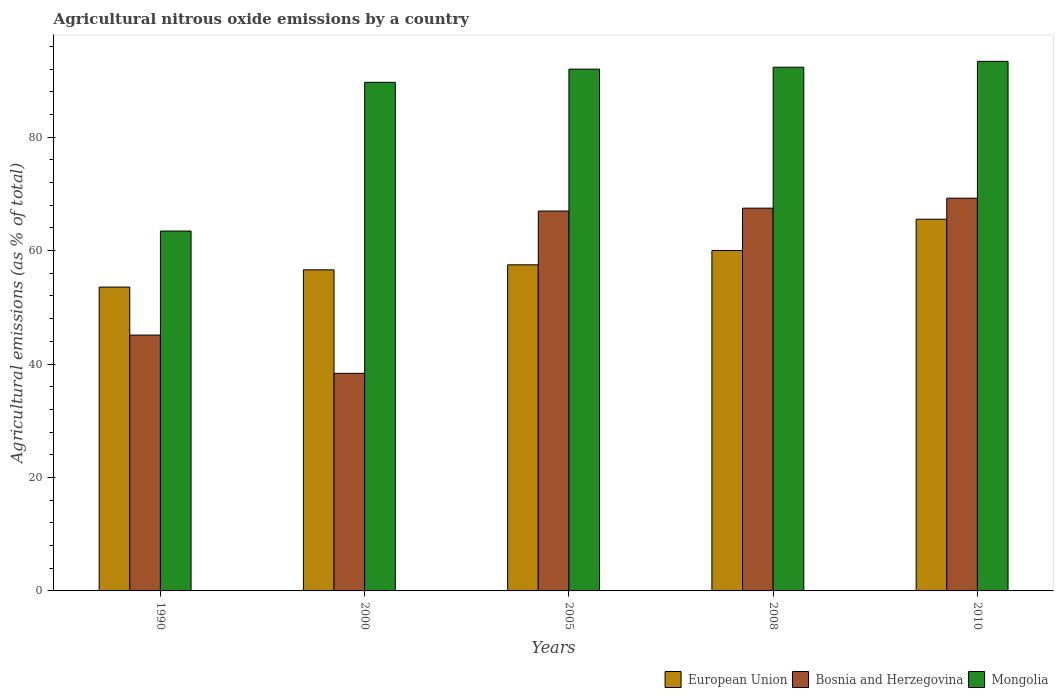How many different coloured bars are there?
Offer a terse response. 3. Are the number of bars per tick equal to the number of legend labels?
Provide a succinct answer. Yes. Are the number of bars on each tick of the X-axis equal?
Offer a terse response. Yes. How many bars are there on the 1st tick from the right?
Provide a short and direct response. 3. What is the label of the 5th group of bars from the left?
Give a very brief answer. 2010. In how many cases, is the number of bars for a given year not equal to the number of legend labels?
Keep it short and to the point. 0. What is the amount of agricultural nitrous oxide emitted in European Union in 2008?
Provide a succinct answer. 60.01. Across all years, what is the maximum amount of agricultural nitrous oxide emitted in European Union?
Your answer should be very brief. 65.53. Across all years, what is the minimum amount of agricultural nitrous oxide emitted in Mongolia?
Provide a short and direct response. 63.44. In which year was the amount of agricultural nitrous oxide emitted in European Union maximum?
Offer a terse response. 2010. In which year was the amount of agricultural nitrous oxide emitted in European Union minimum?
Give a very brief answer. 1990. What is the total amount of agricultural nitrous oxide emitted in European Union in the graph?
Give a very brief answer. 293.19. What is the difference between the amount of agricultural nitrous oxide emitted in European Union in 2000 and that in 2010?
Give a very brief answer. -8.93. What is the difference between the amount of agricultural nitrous oxide emitted in Mongolia in 2008 and the amount of agricultural nitrous oxide emitted in Bosnia and Herzegovina in 2010?
Offer a terse response. 23.09. What is the average amount of agricultural nitrous oxide emitted in Bosnia and Herzegovina per year?
Make the answer very short. 57.43. In the year 1990, what is the difference between the amount of agricultural nitrous oxide emitted in European Union and amount of agricultural nitrous oxide emitted in Bosnia and Herzegovina?
Make the answer very short. 8.46. In how many years, is the amount of agricultural nitrous oxide emitted in European Union greater than 48 %?
Your response must be concise. 5. What is the ratio of the amount of agricultural nitrous oxide emitted in European Union in 2000 to that in 2008?
Provide a succinct answer. 0.94. Is the difference between the amount of agricultural nitrous oxide emitted in European Union in 2005 and 2010 greater than the difference between the amount of agricultural nitrous oxide emitted in Bosnia and Herzegovina in 2005 and 2010?
Provide a succinct answer. No. What is the difference between the highest and the second highest amount of agricultural nitrous oxide emitted in European Union?
Your answer should be compact. 5.51. What is the difference between the highest and the lowest amount of agricultural nitrous oxide emitted in Bosnia and Herzegovina?
Give a very brief answer. 30.88. In how many years, is the amount of agricultural nitrous oxide emitted in European Union greater than the average amount of agricultural nitrous oxide emitted in European Union taken over all years?
Give a very brief answer. 2. Is the sum of the amount of agricultural nitrous oxide emitted in Mongolia in 2005 and 2010 greater than the maximum amount of agricultural nitrous oxide emitted in Bosnia and Herzegovina across all years?
Give a very brief answer. Yes. What does the 2nd bar from the right in 1990 represents?
Offer a terse response. Bosnia and Herzegovina. Is it the case that in every year, the sum of the amount of agricultural nitrous oxide emitted in Mongolia and amount of agricultural nitrous oxide emitted in European Union is greater than the amount of agricultural nitrous oxide emitted in Bosnia and Herzegovina?
Provide a short and direct response. Yes. Are all the bars in the graph horizontal?
Provide a short and direct response. No. Are the values on the major ticks of Y-axis written in scientific E-notation?
Your answer should be very brief. No. Does the graph contain any zero values?
Make the answer very short. No. Does the graph contain grids?
Your answer should be compact. No. Where does the legend appear in the graph?
Offer a very short reply. Bottom right. How many legend labels are there?
Give a very brief answer. 3. How are the legend labels stacked?
Your answer should be very brief. Horizontal. What is the title of the graph?
Your answer should be compact. Agricultural nitrous oxide emissions by a country. What is the label or title of the Y-axis?
Offer a very short reply. Agricultural emissions (as % of total). What is the Agricultural emissions (as % of total) of European Union in 1990?
Offer a very short reply. 53.56. What is the Agricultural emissions (as % of total) in Bosnia and Herzegovina in 1990?
Ensure brevity in your answer.  45.1. What is the Agricultural emissions (as % of total) of Mongolia in 1990?
Provide a short and direct response. 63.44. What is the Agricultural emissions (as % of total) of European Union in 2000?
Offer a terse response. 56.6. What is the Agricultural emissions (as % of total) in Bosnia and Herzegovina in 2000?
Your answer should be compact. 38.36. What is the Agricultural emissions (as % of total) of Mongolia in 2000?
Provide a succinct answer. 89.66. What is the Agricultural emissions (as % of total) in European Union in 2005?
Your response must be concise. 57.49. What is the Agricultural emissions (as % of total) in Bosnia and Herzegovina in 2005?
Give a very brief answer. 66.97. What is the Agricultural emissions (as % of total) of Mongolia in 2005?
Ensure brevity in your answer.  91.98. What is the Agricultural emissions (as % of total) of European Union in 2008?
Your answer should be very brief. 60.01. What is the Agricultural emissions (as % of total) of Bosnia and Herzegovina in 2008?
Provide a succinct answer. 67.47. What is the Agricultural emissions (as % of total) in Mongolia in 2008?
Offer a terse response. 92.32. What is the Agricultural emissions (as % of total) in European Union in 2010?
Ensure brevity in your answer.  65.53. What is the Agricultural emissions (as % of total) in Bosnia and Herzegovina in 2010?
Your response must be concise. 69.23. What is the Agricultural emissions (as % of total) of Mongolia in 2010?
Offer a very short reply. 93.35. Across all years, what is the maximum Agricultural emissions (as % of total) in European Union?
Your answer should be very brief. 65.53. Across all years, what is the maximum Agricultural emissions (as % of total) of Bosnia and Herzegovina?
Provide a short and direct response. 69.23. Across all years, what is the maximum Agricultural emissions (as % of total) of Mongolia?
Offer a very short reply. 93.35. Across all years, what is the minimum Agricultural emissions (as % of total) in European Union?
Ensure brevity in your answer.  53.56. Across all years, what is the minimum Agricultural emissions (as % of total) in Bosnia and Herzegovina?
Offer a very short reply. 38.36. Across all years, what is the minimum Agricultural emissions (as % of total) in Mongolia?
Offer a very short reply. 63.44. What is the total Agricultural emissions (as % of total) of European Union in the graph?
Provide a short and direct response. 293.19. What is the total Agricultural emissions (as % of total) of Bosnia and Herzegovina in the graph?
Keep it short and to the point. 287.13. What is the total Agricultural emissions (as % of total) of Mongolia in the graph?
Provide a succinct answer. 430.75. What is the difference between the Agricultural emissions (as % of total) in European Union in 1990 and that in 2000?
Provide a succinct answer. -3.04. What is the difference between the Agricultural emissions (as % of total) of Bosnia and Herzegovina in 1990 and that in 2000?
Provide a succinct answer. 6.74. What is the difference between the Agricultural emissions (as % of total) of Mongolia in 1990 and that in 2000?
Keep it short and to the point. -26.22. What is the difference between the Agricultural emissions (as % of total) in European Union in 1990 and that in 2005?
Offer a very short reply. -3.92. What is the difference between the Agricultural emissions (as % of total) of Bosnia and Herzegovina in 1990 and that in 2005?
Your answer should be compact. -21.87. What is the difference between the Agricultural emissions (as % of total) of Mongolia in 1990 and that in 2005?
Provide a succinct answer. -28.54. What is the difference between the Agricultural emissions (as % of total) of European Union in 1990 and that in 2008?
Keep it short and to the point. -6.45. What is the difference between the Agricultural emissions (as % of total) in Bosnia and Herzegovina in 1990 and that in 2008?
Your answer should be very brief. -22.37. What is the difference between the Agricultural emissions (as % of total) in Mongolia in 1990 and that in 2008?
Your response must be concise. -28.88. What is the difference between the Agricultural emissions (as % of total) of European Union in 1990 and that in 2010?
Give a very brief answer. -11.97. What is the difference between the Agricultural emissions (as % of total) in Bosnia and Herzegovina in 1990 and that in 2010?
Offer a very short reply. -24.13. What is the difference between the Agricultural emissions (as % of total) of Mongolia in 1990 and that in 2010?
Your response must be concise. -29.91. What is the difference between the Agricultural emissions (as % of total) in European Union in 2000 and that in 2005?
Keep it short and to the point. -0.89. What is the difference between the Agricultural emissions (as % of total) in Bosnia and Herzegovina in 2000 and that in 2005?
Provide a short and direct response. -28.61. What is the difference between the Agricultural emissions (as % of total) in Mongolia in 2000 and that in 2005?
Offer a very short reply. -2.32. What is the difference between the Agricultural emissions (as % of total) of European Union in 2000 and that in 2008?
Provide a succinct answer. -3.41. What is the difference between the Agricultural emissions (as % of total) of Bosnia and Herzegovina in 2000 and that in 2008?
Offer a very short reply. -29.12. What is the difference between the Agricultural emissions (as % of total) of Mongolia in 2000 and that in 2008?
Provide a short and direct response. -2.66. What is the difference between the Agricultural emissions (as % of total) in European Union in 2000 and that in 2010?
Offer a very short reply. -8.93. What is the difference between the Agricultural emissions (as % of total) of Bosnia and Herzegovina in 2000 and that in 2010?
Your answer should be compact. -30.88. What is the difference between the Agricultural emissions (as % of total) of Mongolia in 2000 and that in 2010?
Keep it short and to the point. -3.7. What is the difference between the Agricultural emissions (as % of total) in European Union in 2005 and that in 2008?
Ensure brevity in your answer.  -2.53. What is the difference between the Agricultural emissions (as % of total) in Bosnia and Herzegovina in 2005 and that in 2008?
Your response must be concise. -0.51. What is the difference between the Agricultural emissions (as % of total) of Mongolia in 2005 and that in 2008?
Give a very brief answer. -0.34. What is the difference between the Agricultural emissions (as % of total) of European Union in 2005 and that in 2010?
Keep it short and to the point. -8.04. What is the difference between the Agricultural emissions (as % of total) in Bosnia and Herzegovina in 2005 and that in 2010?
Keep it short and to the point. -2.27. What is the difference between the Agricultural emissions (as % of total) in Mongolia in 2005 and that in 2010?
Make the answer very short. -1.37. What is the difference between the Agricultural emissions (as % of total) of European Union in 2008 and that in 2010?
Provide a short and direct response. -5.51. What is the difference between the Agricultural emissions (as % of total) of Bosnia and Herzegovina in 2008 and that in 2010?
Provide a short and direct response. -1.76. What is the difference between the Agricultural emissions (as % of total) of Mongolia in 2008 and that in 2010?
Offer a very short reply. -1.03. What is the difference between the Agricultural emissions (as % of total) of European Union in 1990 and the Agricultural emissions (as % of total) of Bosnia and Herzegovina in 2000?
Your answer should be compact. 15.2. What is the difference between the Agricultural emissions (as % of total) in European Union in 1990 and the Agricultural emissions (as % of total) in Mongolia in 2000?
Provide a succinct answer. -36.1. What is the difference between the Agricultural emissions (as % of total) of Bosnia and Herzegovina in 1990 and the Agricultural emissions (as % of total) of Mongolia in 2000?
Offer a terse response. -44.56. What is the difference between the Agricultural emissions (as % of total) in European Union in 1990 and the Agricultural emissions (as % of total) in Bosnia and Herzegovina in 2005?
Ensure brevity in your answer.  -13.41. What is the difference between the Agricultural emissions (as % of total) in European Union in 1990 and the Agricultural emissions (as % of total) in Mongolia in 2005?
Your answer should be very brief. -38.42. What is the difference between the Agricultural emissions (as % of total) in Bosnia and Herzegovina in 1990 and the Agricultural emissions (as % of total) in Mongolia in 2005?
Keep it short and to the point. -46.88. What is the difference between the Agricultural emissions (as % of total) in European Union in 1990 and the Agricultural emissions (as % of total) in Bosnia and Herzegovina in 2008?
Your answer should be compact. -13.91. What is the difference between the Agricultural emissions (as % of total) in European Union in 1990 and the Agricultural emissions (as % of total) in Mongolia in 2008?
Offer a very short reply. -38.76. What is the difference between the Agricultural emissions (as % of total) of Bosnia and Herzegovina in 1990 and the Agricultural emissions (as % of total) of Mongolia in 2008?
Give a very brief answer. -47.22. What is the difference between the Agricultural emissions (as % of total) of European Union in 1990 and the Agricultural emissions (as % of total) of Bosnia and Herzegovina in 2010?
Give a very brief answer. -15.67. What is the difference between the Agricultural emissions (as % of total) in European Union in 1990 and the Agricultural emissions (as % of total) in Mongolia in 2010?
Your answer should be very brief. -39.79. What is the difference between the Agricultural emissions (as % of total) of Bosnia and Herzegovina in 1990 and the Agricultural emissions (as % of total) of Mongolia in 2010?
Provide a succinct answer. -48.25. What is the difference between the Agricultural emissions (as % of total) of European Union in 2000 and the Agricultural emissions (as % of total) of Bosnia and Herzegovina in 2005?
Give a very brief answer. -10.37. What is the difference between the Agricultural emissions (as % of total) in European Union in 2000 and the Agricultural emissions (as % of total) in Mongolia in 2005?
Make the answer very short. -35.38. What is the difference between the Agricultural emissions (as % of total) in Bosnia and Herzegovina in 2000 and the Agricultural emissions (as % of total) in Mongolia in 2005?
Your answer should be compact. -53.62. What is the difference between the Agricultural emissions (as % of total) of European Union in 2000 and the Agricultural emissions (as % of total) of Bosnia and Herzegovina in 2008?
Give a very brief answer. -10.87. What is the difference between the Agricultural emissions (as % of total) of European Union in 2000 and the Agricultural emissions (as % of total) of Mongolia in 2008?
Offer a very short reply. -35.72. What is the difference between the Agricultural emissions (as % of total) in Bosnia and Herzegovina in 2000 and the Agricultural emissions (as % of total) in Mongolia in 2008?
Ensure brevity in your answer.  -53.96. What is the difference between the Agricultural emissions (as % of total) of European Union in 2000 and the Agricultural emissions (as % of total) of Bosnia and Herzegovina in 2010?
Ensure brevity in your answer.  -12.63. What is the difference between the Agricultural emissions (as % of total) in European Union in 2000 and the Agricultural emissions (as % of total) in Mongolia in 2010?
Your response must be concise. -36.75. What is the difference between the Agricultural emissions (as % of total) of Bosnia and Herzegovina in 2000 and the Agricultural emissions (as % of total) of Mongolia in 2010?
Give a very brief answer. -55. What is the difference between the Agricultural emissions (as % of total) in European Union in 2005 and the Agricultural emissions (as % of total) in Bosnia and Herzegovina in 2008?
Give a very brief answer. -9.99. What is the difference between the Agricultural emissions (as % of total) of European Union in 2005 and the Agricultural emissions (as % of total) of Mongolia in 2008?
Ensure brevity in your answer.  -34.83. What is the difference between the Agricultural emissions (as % of total) in Bosnia and Herzegovina in 2005 and the Agricultural emissions (as % of total) in Mongolia in 2008?
Keep it short and to the point. -25.35. What is the difference between the Agricultural emissions (as % of total) in European Union in 2005 and the Agricultural emissions (as % of total) in Bosnia and Herzegovina in 2010?
Provide a short and direct response. -11.75. What is the difference between the Agricultural emissions (as % of total) in European Union in 2005 and the Agricultural emissions (as % of total) in Mongolia in 2010?
Offer a very short reply. -35.87. What is the difference between the Agricultural emissions (as % of total) in Bosnia and Herzegovina in 2005 and the Agricultural emissions (as % of total) in Mongolia in 2010?
Your answer should be very brief. -26.39. What is the difference between the Agricultural emissions (as % of total) in European Union in 2008 and the Agricultural emissions (as % of total) in Bosnia and Herzegovina in 2010?
Make the answer very short. -9.22. What is the difference between the Agricultural emissions (as % of total) in European Union in 2008 and the Agricultural emissions (as % of total) in Mongolia in 2010?
Your response must be concise. -33.34. What is the difference between the Agricultural emissions (as % of total) in Bosnia and Herzegovina in 2008 and the Agricultural emissions (as % of total) in Mongolia in 2010?
Provide a succinct answer. -25.88. What is the average Agricultural emissions (as % of total) of European Union per year?
Provide a short and direct response. 58.64. What is the average Agricultural emissions (as % of total) in Bosnia and Herzegovina per year?
Your response must be concise. 57.43. What is the average Agricultural emissions (as % of total) of Mongolia per year?
Provide a short and direct response. 86.15. In the year 1990, what is the difference between the Agricultural emissions (as % of total) in European Union and Agricultural emissions (as % of total) in Bosnia and Herzegovina?
Your answer should be very brief. 8.46. In the year 1990, what is the difference between the Agricultural emissions (as % of total) of European Union and Agricultural emissions (as % of total) of Mongolia?
Provide a short and direct response. -9.88. In the year 1990, what is the difference between the Agricultural emissions (as % of total) of Bosnia and Herzegovina and Agricultural emissions (as % of total) of Mongolia?
Offer a terse response. -18.34. In the year 2000, what is the difference between the Agricultural emissions (as % of total) in European Union and Agricultural emissions (as % of total) in Bosnia and Herzegovina?
Provide a short and direct response. 18.24. In the year 2000, what is the difference between the Agricultural emissions (as % of total) in European Union and Agricultural emissions (as % of total) in Mongolia?
Offer a very short reply. -33.06. In the year 2000, what is the difference between the Agricultural emissions (as % of total) in Bosnia and Herzegovina and Agricultural emissions (as % of total) in Mongolia?
Your answer should be compact. -51.3. In the year 2005, what is the difference between the Agricultural emissions (as % of total) in European Union and Agricultural emissions (as % of total) in Bosnia and Herzegovina?
Your answer should be compact. -9.48. In the year 2005, what is the difference between the Agricultural emissions (as % of total) of European Union and Agricultural emissions (as % of total) of Mongolia?
Offer a very short reply. -34.49. In the year 2005, what is the difference between the Agricultural emissions (as % of total) in Bosnia and Herzegovina and Agricultural emissions (as % of total) in Mongolia?
Offer a terse response. -25.01. In the year 2008, what is the difference between the Agricultural emissions (as % of total) of European Union and Agricultural emissions (as % of total) of Bosnia and Herzegovina?
Keep it short and to the point. -7.46. In the year 2008, what is the difference between the Agricultural emissions (as % of total) of European Union and Agricultural emissions (as % of total) of Mongolia?
Keep it short and to the point. -32.3. In the year 2008, what is the difference between the Agricultural emissions (as % of total) in Bosnia and Herzegovina and Agricultural emissions (as % of total) in Mongolia?
Make the answer very short. -24.84. In the year 2010, what is the difference between the Agricultural emissions (as % of total) of European Union and Agricultural emissions (as % of total) of Bosnia and Herzegovina?
Provide a succinct answer. -3.71. In the year 2010, what is the difference between the Agricultural emissions (as % of total) in European Union and Agricultural emissions (as % of total) in Mongolia?
Ensure brevity in your answer.  -27.82. In the year 2010, what is the difference between the Agricultural emissions (as % of total) of Bosnia and Herzegovina and Agricultural emissions (as % of total) of Mongolia?
Offer a very short reply. -24.12. What is the ratio of the Agricultural emissions (as % of total) in European Union in 1990 to that in 2000?
Provide a short and direct response. 0.95. What is the ratio of the Agricultural emissions (as % of total) in Bosnia and Herzegovina in 1990 to that in 2000?
Your response must be concise. 1.18. What is the ratio of the Agricultural emissions (as % of total) of Mongolia in 1990 to that in 2000?
Offer a terse response. 0.71. What is the ratio of the Agricultural emissions (as % of total) in European Union in 1990 to that in 2005?
Your answer should be very brief. 0.93. What is the ratio of the Agricultural emissions (as % of total) of Bosnia and Herzegovina in 1990 to that in 2005?
Your answer should be compact. 0.67. What is the ratio of the Agricultural emissions (as % of total) of Mongolia in 1990 to that in 2005?
Your answer should be very brief. 0.69. What is the ratio of the Agricultural emissions (as % of total) in European Union in 1990 to that in 2008?
Offer a terse response. 0.89. What is the ratio of the Agricultural emissions (as % of total) of Bosnia and Herzegovina in 1990 to that in 2008?
Ensure brevity in your answer.  0.67. What is the ratio of the Agricultural emissions (as % of total) of Mongolia in 1990 to that in 2008?
Provide a succinct answer. 0.69. What is the ratio of the Agricultural emissions (as % of total) of European Union in 1990 to that in 2010?
Ensure brevity in your answer.  0.82. What is the ratio of the Agricultural emissions (as % of total) of Bosnia and Herzegovina in 1990 to that in 2010?
Provide a short and direct response. 0.65. What is the ratio of the Agricultural emissions (as % of total) in Mongolia in 1990 to that in 2010?
Make the answer very short. 0.68. What is the ratio of the Agricultural emissions (as % of total) in European Union in 2000 to that in 2005?
Provide a short and direct response. 0.98. What is the ratio of the Agricultural emissions (as % of total) of Bosnia and Herzegovina in 2000 to that in 2005?
Your answer should be compact. 0.57. What is the ratio of the Agricultural emissions (as % of total) in Mongolia in 2000 to that in 2005?
Provide a short and direct response. 0.97. What is the ratio of the Agricultural emissions (as % of total) of European Union in 2000 to that in 2008?
Keep it short and to the point. 0.94. What is the ratio of the Agricultural emissions (as % of total) of Bosnia and Herzegovina in 2000 to that in 2008?
Ensure brevity in your answer.  0.57. What is the ratio of the Agricultural emissions (as % of total) in Mongolia in 2000 to that in 2008?
Your answer should be compact. 0.97. What is the ratio of the Agricultural emissions (as % of total) of European Union in 2000 to that in 2010?
Provide a short and direct response. 0.86. What is the ratio of the Agricultural emissions (as % of total) of Bosnia and Herzegovina in 2000 to that in 2010?
Ensure brevity in your answer.  0.55. What is the ratio of the Agricultural emissions (as % of total) of Mongolia in 2000 to that in 2010?
Your response must be concise. 0.96. What is the ratio of the Agricultural emissions (as % of total) in European Union in 2005 to that in 2008?
Provide a succinct answer. 0.96. What is the ratio of the Agricultural emissions (as % of total) of European Union in 2005 to that in 2010?
Your answer should be compact. 0.88. What is the ratio of the Agricultural emissions (as % of total) in Bosnia and Herzegovina in 2005 to that in 2010?
Your answer should be compact. 0.97. What is the ratio of the Agricultural emissions (as % of total) in European Union in 2008 to that in 2010?
Offer a very short reply. 0.92. What is the ratio of the Agricultural emissions (as % of total) in Bosnia and Herzegovina in 2008 to that in 2010?
Your answer should be compact. 0.97. What is the ratio of the Agricultural emissions (as % of total) of Mongolia in 2008 to that in 2010?
Your response must be concise. 0.99. What is the difference between the highest and the second highest Agricultural emissions (as % of total) of European Union?
Provide a succinct answer. 5.51. What is the difference between the highest and the second highest Agricultural emissions (as % of total) of Bosnia and Herzegovina?
Keep it short and to the point. 1.76. What is the difference between the highest and the second highest Agricultural emissions (as % of total) in Mongolia?
Your answer should be very brief. 1.03. What is the difference between the highest and the lowest Agricultural emissions (as % of total) of European Union?
Provide a short and direct response. 11.97. What is the difference between the highest and the lowest Agricultural emissions (as % of total) of Bosnia and Herzegovina?
Keep it short and to the point. 30.88. What is the difference between the highest and the lowest Agricultural emissions (as % of total) in Mongolia?
Offer a terse response. 29.91. 